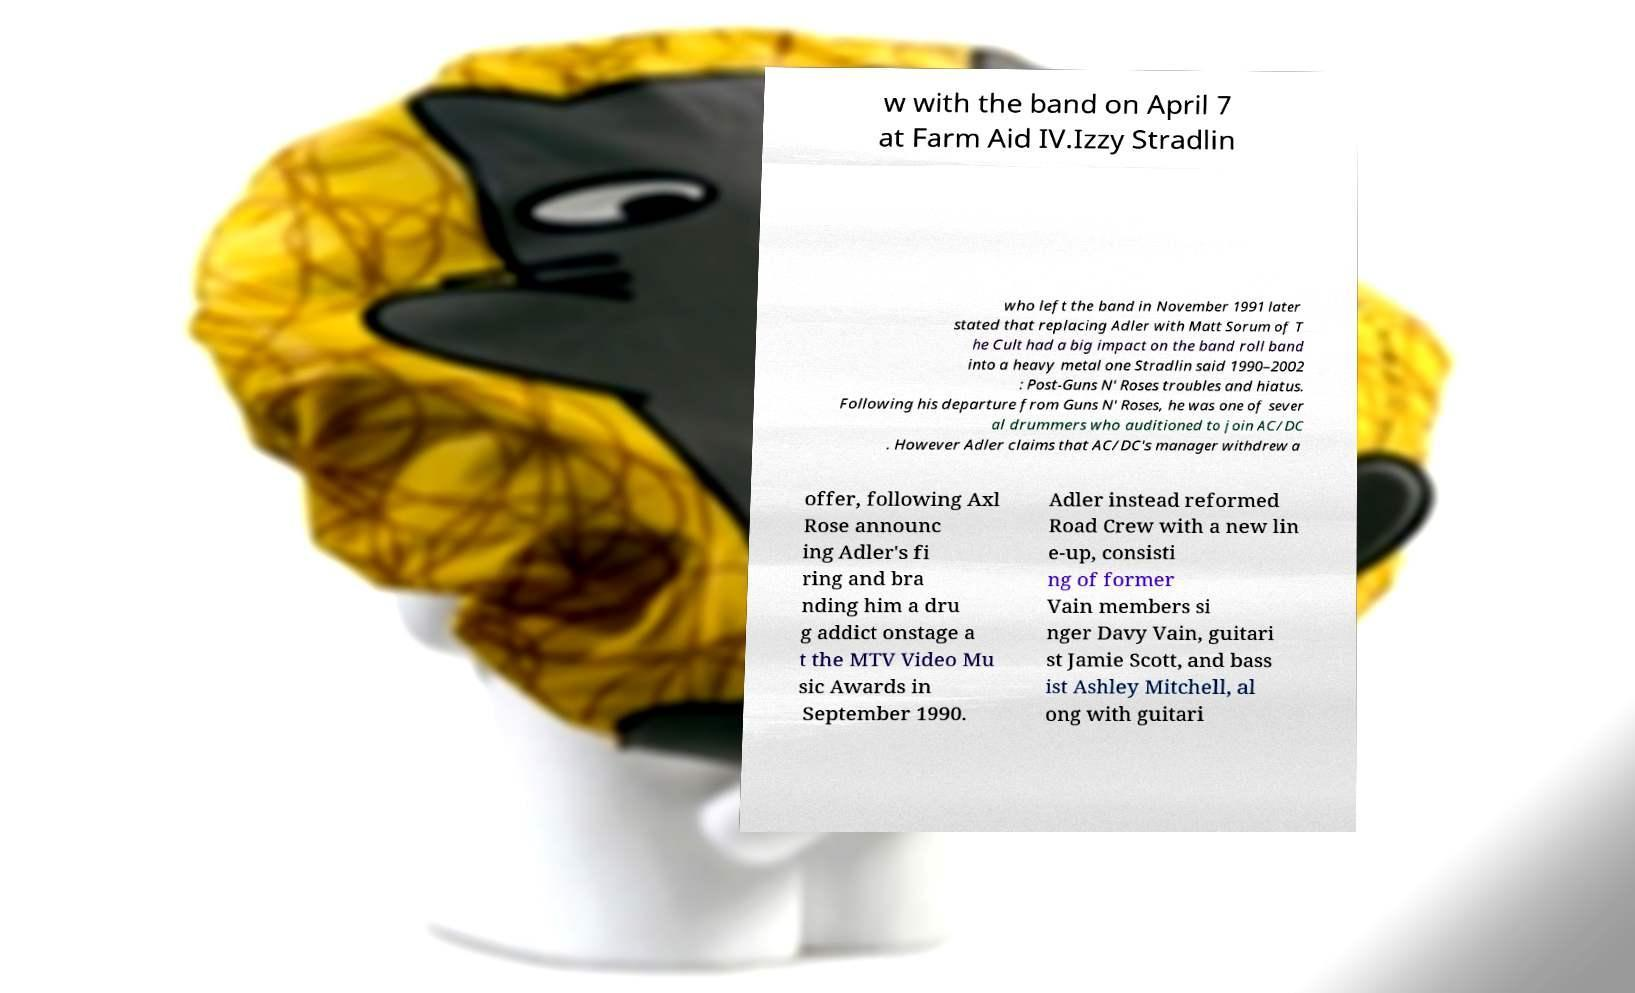There's text embedded in this image that I need extracted. Can you transcribe it verbatim? w with the band on April 7 at Farm Aid IV.Izzy Stradlin who left the band in November 1991 later stated that replacing Adler with Matt Sorum of T he Cult had a big impact on the band roll band into a heavy metal one Stradlin said 1990–2002 : Post-Guns N' Roses troubles and hiatus. Following his departure from Guns N' Roses, he was one of sever al drummers who auditioned to join AC/DC . However Adler claims that AC/DC's manager withdrew a offer, following Axl Rose announc ing Adler's fi ring and bra nding him a dru g addict onstage a t the MTV Video Mu sic Awards in September 1990. Adler instead reformed Road Crew with a new lin e-up, consisti ng of former Vain members si nger Davy Vain, guitari st Jamie Scott, and bass ist Ashley Mitchell, al ong with guitari 